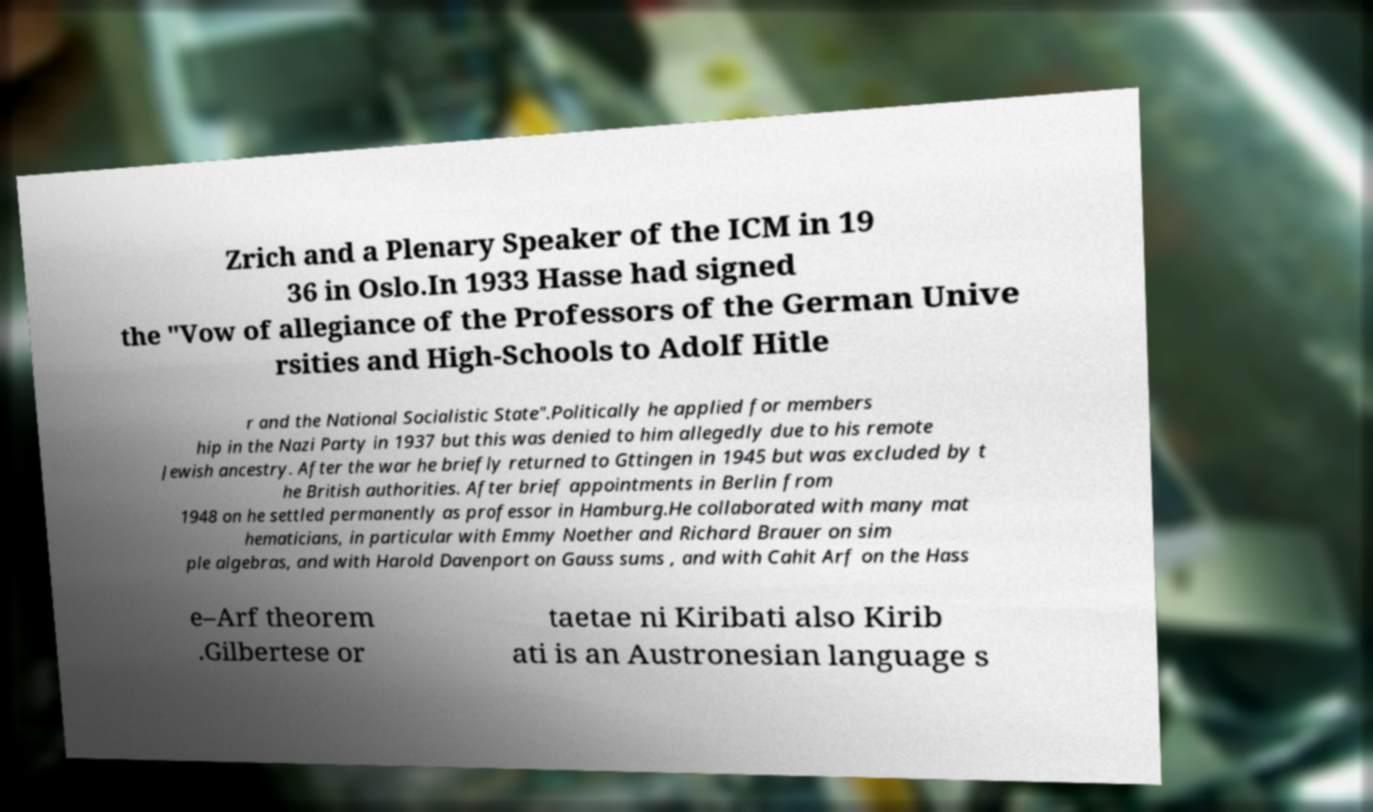I need the written content from this picture converted into text. Can you do that? Zrich and a Plenary Speaker of the ICM in 19 36 in Oslo.In 1933 Hasse had signed the "Vow of allegiance of the Professors of the German Unive rsities and High-Schools to Adolf Hitle r and the National Socialistic State".Politically he applied for members hip in the Nazi Party in 1937 but this was denied to him allegedly due to his remote Jewish ancestry. After the war he briefly returned to Gttingen in 1945 but was excluded by t he British authorities. After brief appointments in Berlin from 1948 on he settled permanently as professor in Hamburg.He collaborated with many mat hematicians, in particular with Emmy Noether and Richard Brauer on sim ple algebras, and with Harold Davenport on Gauss sums , and with Cahit Arf on the Hass e–Arf theorem .Gilbertese or taetae ni Kiribati also Kirib ati is an Austronesian language s 